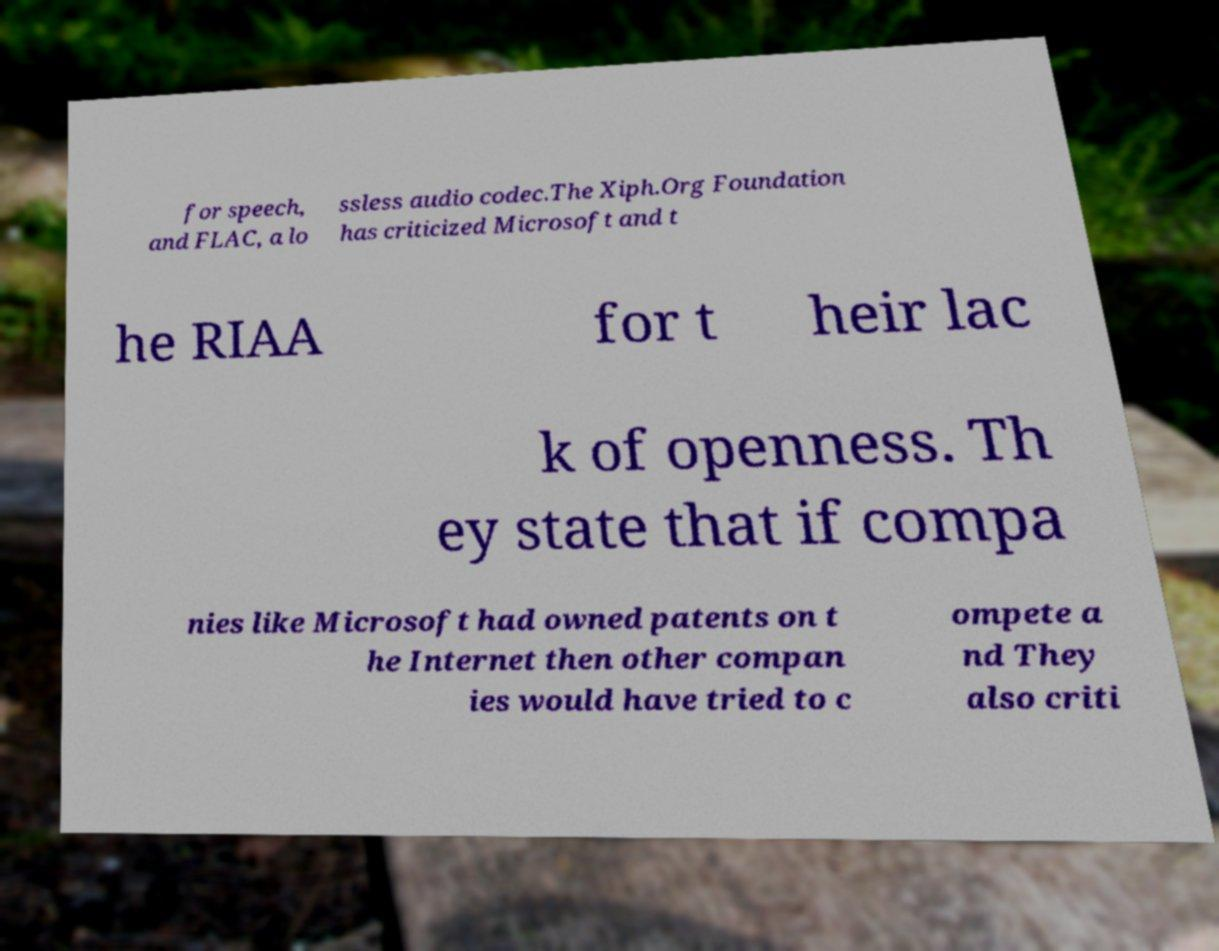Could you extract and type out the text from this image? for speech, and FLAC, a lo ssless audio codec.The Xiph.Org Foundation has criticized Microsoft and t he RIAA for t heir lac k of openness. Th ey state that if compa nies like Microsoft had owned patents on t he Internet then other compan ies would have tried to c ompete a nd They also criti 